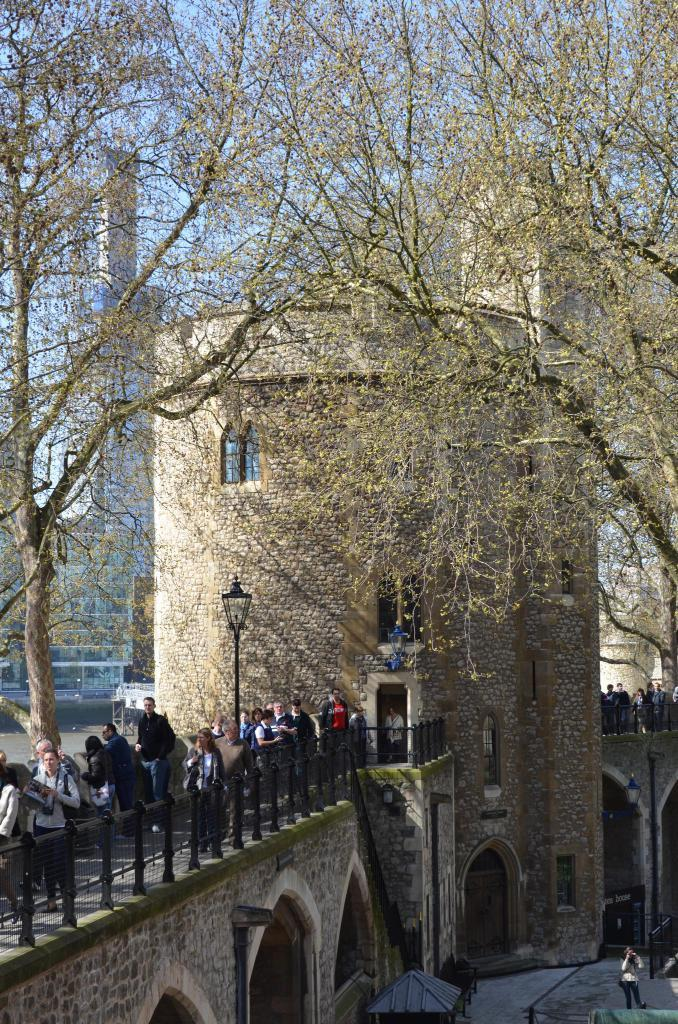What are the people in the image doing? The people in the image are standing on a bridge. What type of vegetation can be seen in the image? There are trees in the image. What is visible in the background of the image? There is a building in the background of the image. What is the condition of the sky in the image? The sky is clear in the image. What type of rice can be seen growing near the bridge in the image? There is no rice visible in the image; it features people standing on a bridge, trees, a building in the background, and a clear sky. How many sheep are present on the bridge in the image? There are no sheep present in the image; it features people standing on a bridge, trees, a building in the background, and a clear sky. 